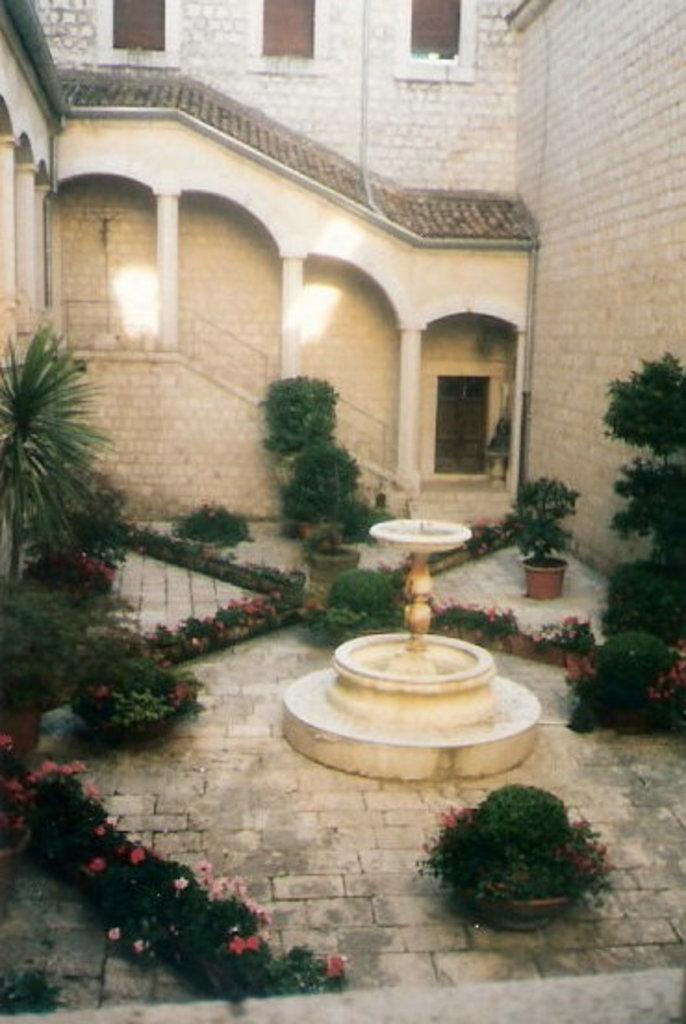What is the main feature in the center of the image? There is a fountain in the center of the image. What can be seen in the background of the image? There are flower pots and plants in the background. Are there any architectural features visible in the background? Yes, there is a building with stairs in the background. What type of wool is being used to create the fountain in the image? There is no wool present in the image; the fountain is made of water and other materials. Can you see the skin of the person operating the fountain in the image? There is no person operating the fountain in the image, so it is not possible to see their skin. 